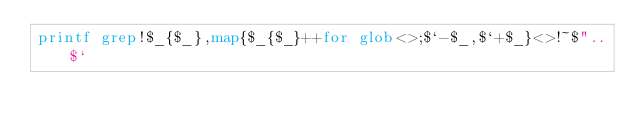Convert code to text. <code><loc_0><loc_0><loc_500><loc_500><_Perl_>printf grep!$_{$_},map{$_{$_}++for glob<>;$`-$_,$`+$_}<>!~$"..$`</code> 